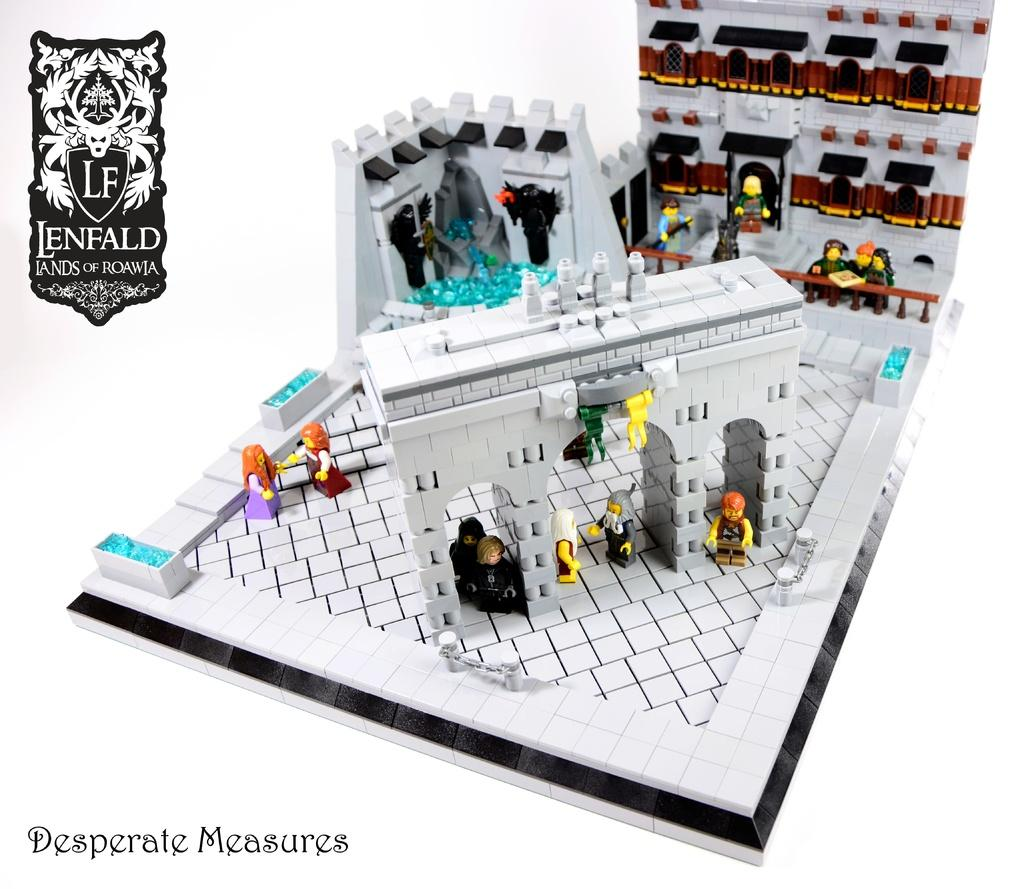What type of objects can be seen in the image? There are toys in the image, including a building made of Lego. Can you describe the logo in the image? There is a logo in the top left and bottom left of the image, and it has text on it. How many logos are present in the image? There are two logos in the image, one in the top left and one in the bottom left. What type of plant can be seen growing in the image? There is no plant visible in the image; it features toys and a Lego building. Can you describe the rock formation in the image? There is no rock formation present in the image. 